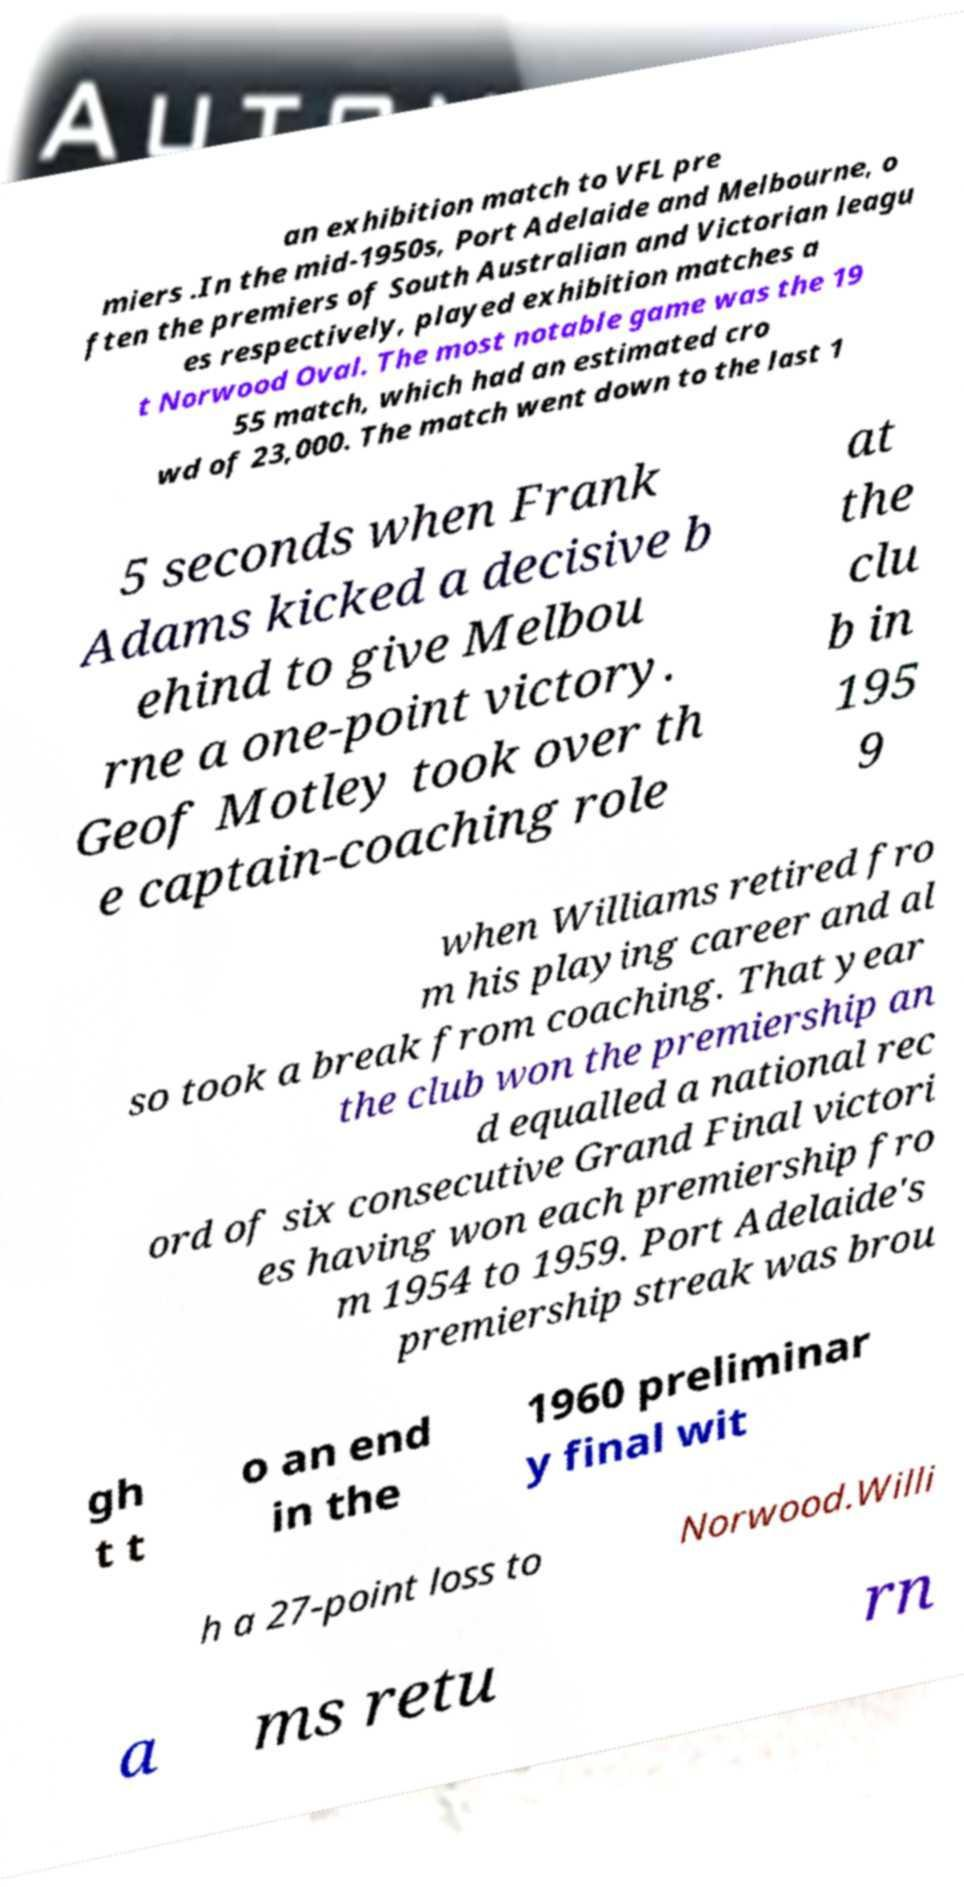There's text embedded in this image that I need extracted. Can you transcribe it verbatim? an exhibition match to VFL pre miers .In the mid-1950s, Port Adelaide and Melbourne, o ften the premiers of South Australian and Victorian leagu es respectively, played exhibition matches a t Norwood Oval. The most notable game was the 19 55 match, which had an estimated cro wd of 23,000. The match went down to the last 1 5 seconds when Frank Adams kicked a decisive b ehind to give Melbou rne a one-point victory. Geof Motley took over th e captain-coaching role at the clu b in 195 9 when Williams retired fro m his playing career and al so took a break from coaching. That year the club won the premiership an d equalled a national rec ord of six consecutive Grand Final victori es having won each premiership fro m 1954 to 1959. Port Adelaide's premiership streak was brou gh t t o an end in the 1960 preliminar y final wit h a 27-point loss to Norwood.Willi a ms retu rn 